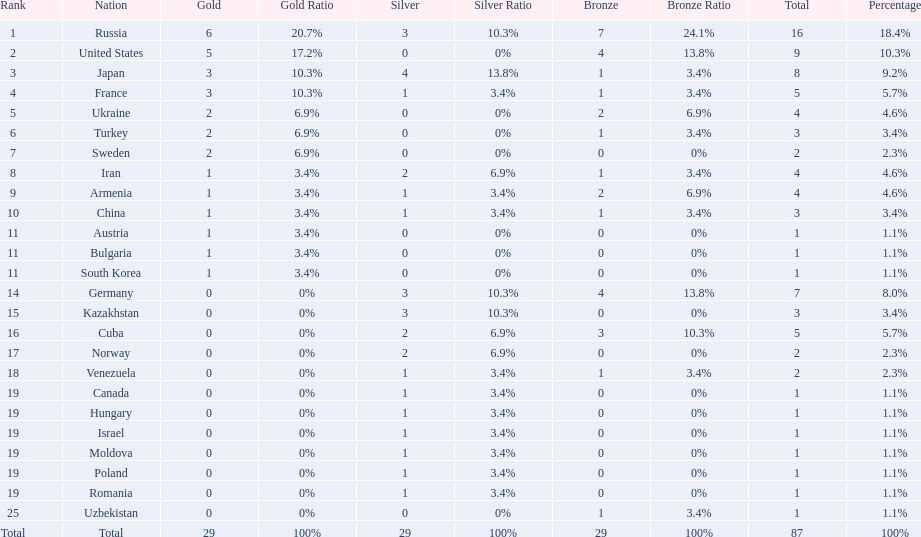How many gold medals did the united states win? 5. Who won more than 5 gold medals? Russia. 